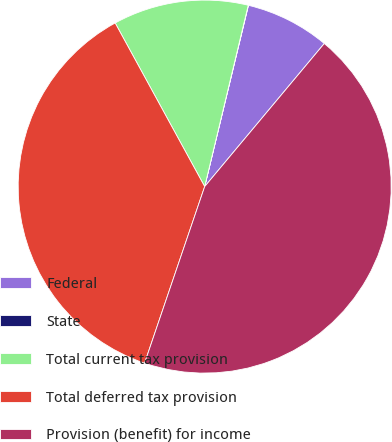Convert chart. <chart><loc_0><loc_0><loc_500><loc_500><pie_chart><fcel>Federal<fcel>State<fcel>Total current tax provision<fcel>Total deferred tax provision<fcel>Provision (benefit) for income<nl><fcel>7.31%<fcel>0.02%<fcel>11.72%<fcel>36.81%<fcel>44.14%<nl></chart> 